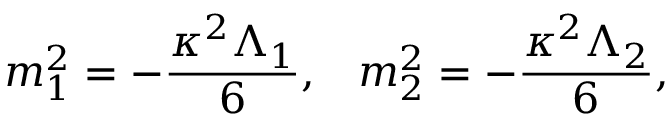Convert formula to latex. <formula><loc_0><loc_0><loc_500><loc_500>m _ { 1 } ^ { 2 } = - \frac { \kappa ^ { 2 } \Lambda _ { 1 } } { 6 } , \, m _ { 2 } ^ { 2 } = - \frac { \kappa ^ { 2 } \Lambda _ { 2 } } { 6 } ,</formula> 